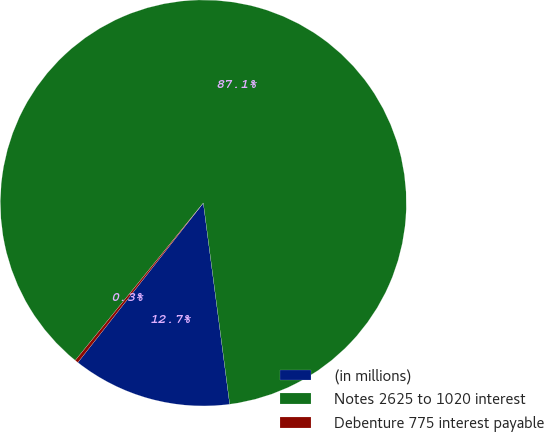Convert chart to OTSL. <chart><loc_0><loc_0><loc_500><loc_500><pie_chart><fcel>(in millions)<fcel>Notes 2625 to 1020 interest<fcel>Debenture 775 interest payable<nl><fcel>12.68%<fcel>87.05%<fcel>0.26%<nl></chart> 